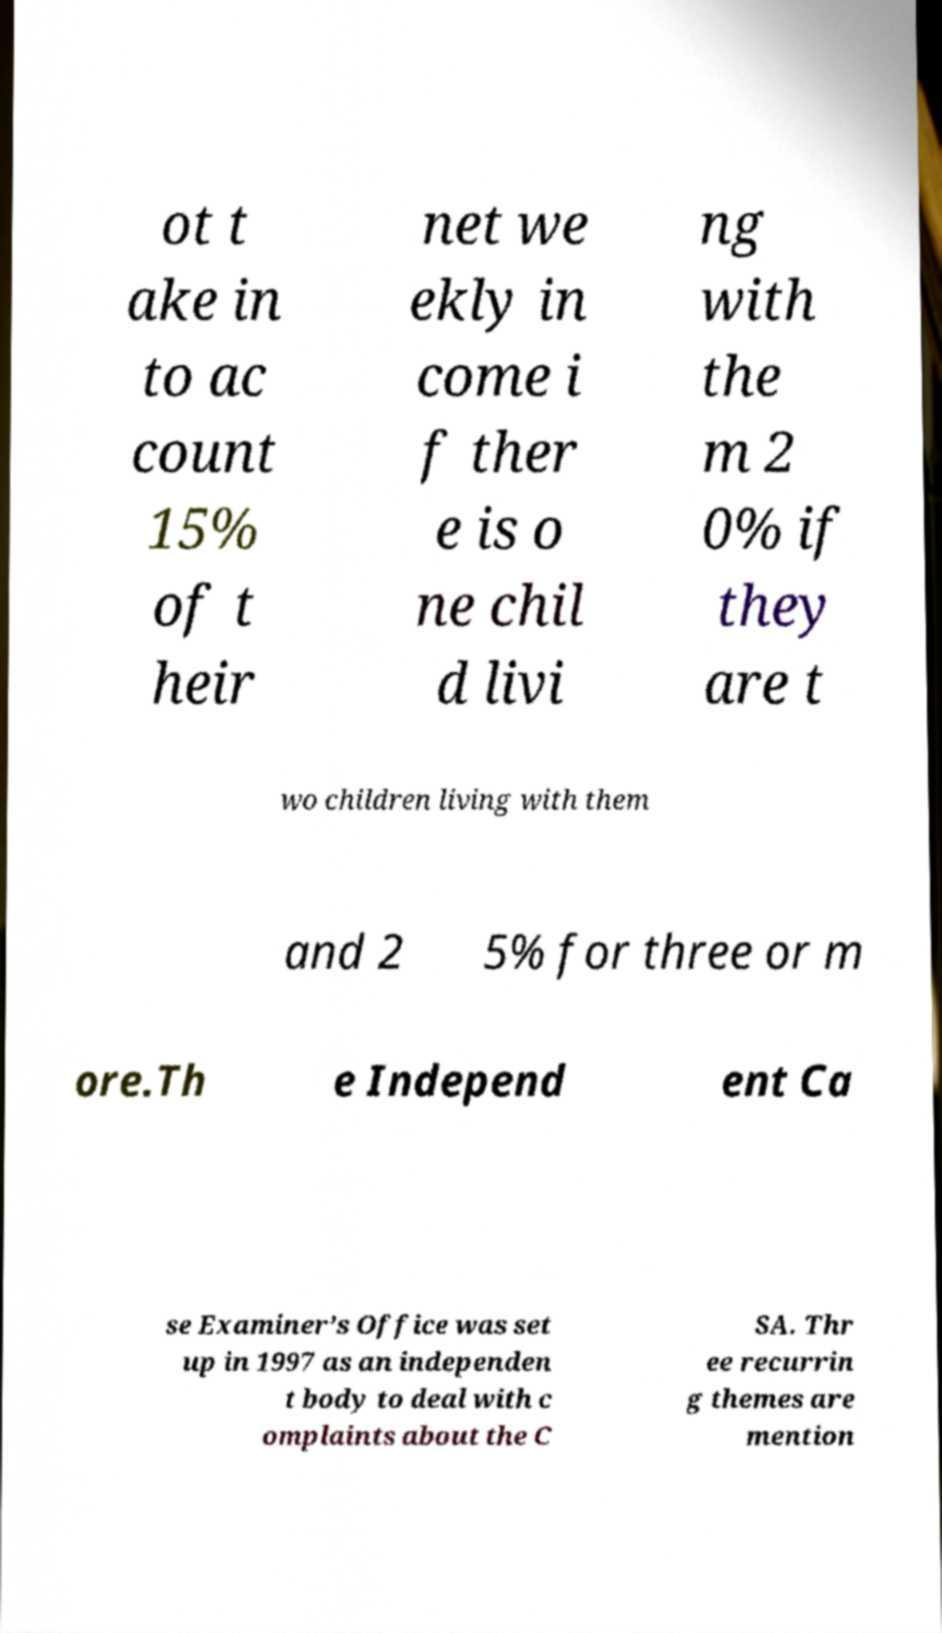Can you accurately transcribe the text from the provided image for me? ot t ake in to ac count 15% of t heir net we ekly in come i f ther e is o ne chil d livi ng with the m 2 0% if they are t wo children living with them and 2 5% for three or m ore.Th e Independ ent Ca se Examiner’s Office was set up in 1997 as an independen t body to deal with c omplaints about the C SA. Thr ee recurrin g themes are mention 